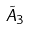<formula> <loc_0><loc_0><loc_500><loc_500>\tilde { A } _ { 3 }</formula> 